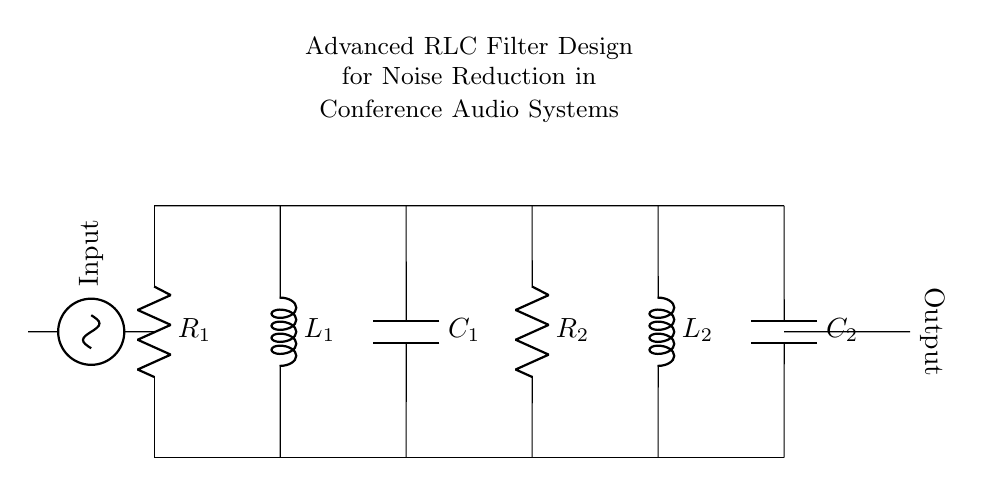What are the components used in this filter circuit? The components in the circuit diagram are resistors, inductors, and capacitors, specifically R1, R2, L1, L2, C1, and C2.
Answer: Resistors, inductors, capacitors What is the role of L1 in this design? L1 is an inductor which is used to store energy in the magnetic field and help filter out high-frequency noise from the audio signal.
Answer: Energy storage, noise filtering How many capacitors are present in the circuit? Capacitors are represented by the components C1 and C2 in the diagram, indicating there are two capacitors present in the circuit.
Answer: Two What type of filter does this RLC circuit represent? This specific configuration suggests it is a band-pass filter, allowing certain frequency ranges to pass while rejecting others based on the arrangement of resistors, inductors, and capacitors.
Answer: Band-pass filter How does the arrangement of R1 and R2 impact the circuit? R1 and R2 determine the resistance in the circuit which affects the damping factor and bandwidth of the filter, thus influencing noise reduction effectiveness.
Answer: Influence damping and bandwidth What is the input voltage represented in the circuit? The input voltage is indicated at the left side of the circuit, labeled as "Input", but the actual value is not specified in the diagram.
Answer: Not specified 